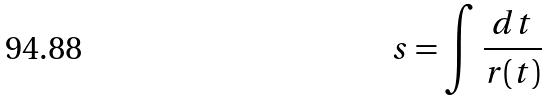Convert formula to latex. <formula><loc_0><loc_0><loc_500><loc_500>s = \int \frac { d t } { r ( t ) }</formula> 